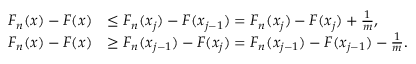Convert formula to latex. <formula><loc_0><loc_0><loc_500><loc_500>{ \begin{array} { r l } { F _ { n } ( x ) - F ( x ) } & { \leq F _ { n } ( x _ { j } ) - F ( x _ { j - 1 } ) = F _ { n } ( x _ { j } ) - F ( x _ { j } ) + { \frac { 1 } { m } } , } \\ { F _ { n } ( x ) - F ( x ) } & { \geq F _ { n } ( x _ { j - 1 } ) - F ( x _ { j } ) = F _ { n } ( x _ { j - 1 } ) - F ( x _ { j - 1 } ) - { \frac { 1 } { m } } . } \end{array} }</formula> 